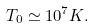<formula> <loc_0><loc_0><loc_500><loc_500>T _ { 0 } \simeq 1 0 ^ { 7 } K .</formula> 